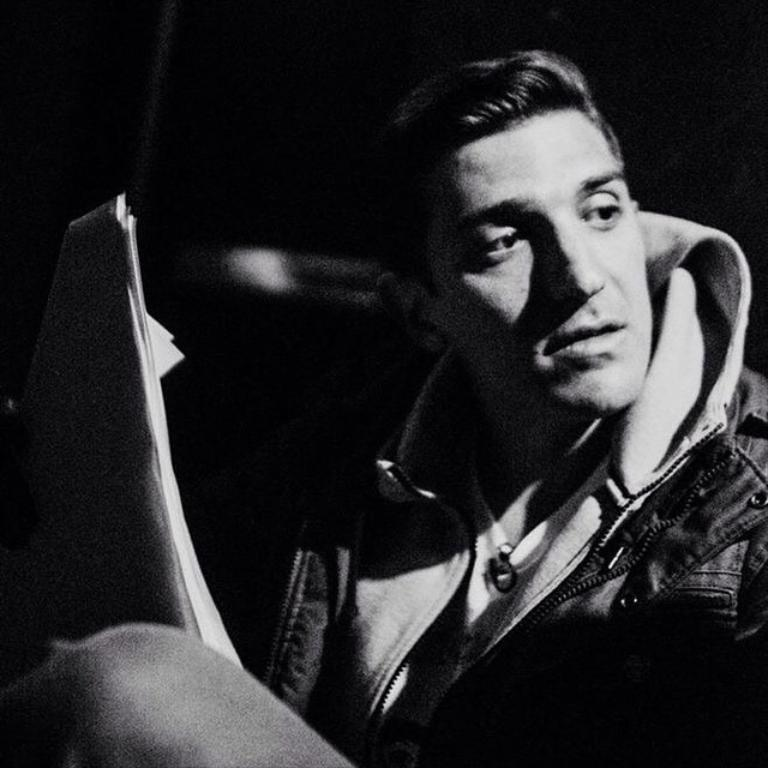Who is present in the image? There is a man in the image. What is the man doing in the image? The man is sitting and holding papers. What is the man's focus in the image? The man is watching something. What type of boot is the man wearing in the image? There is no mention of boots or footwear in the image, so it cannot be determined what type of boot the man might be wearing. 